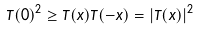Convert formula to latex. <formula><loc_0><loc_0><loc_500><loc_500>T ( 0 ) ^ { 2 } \geq T ( x ) T ( - x ) = | T ( x ) | ^ { 2 }</formula> 